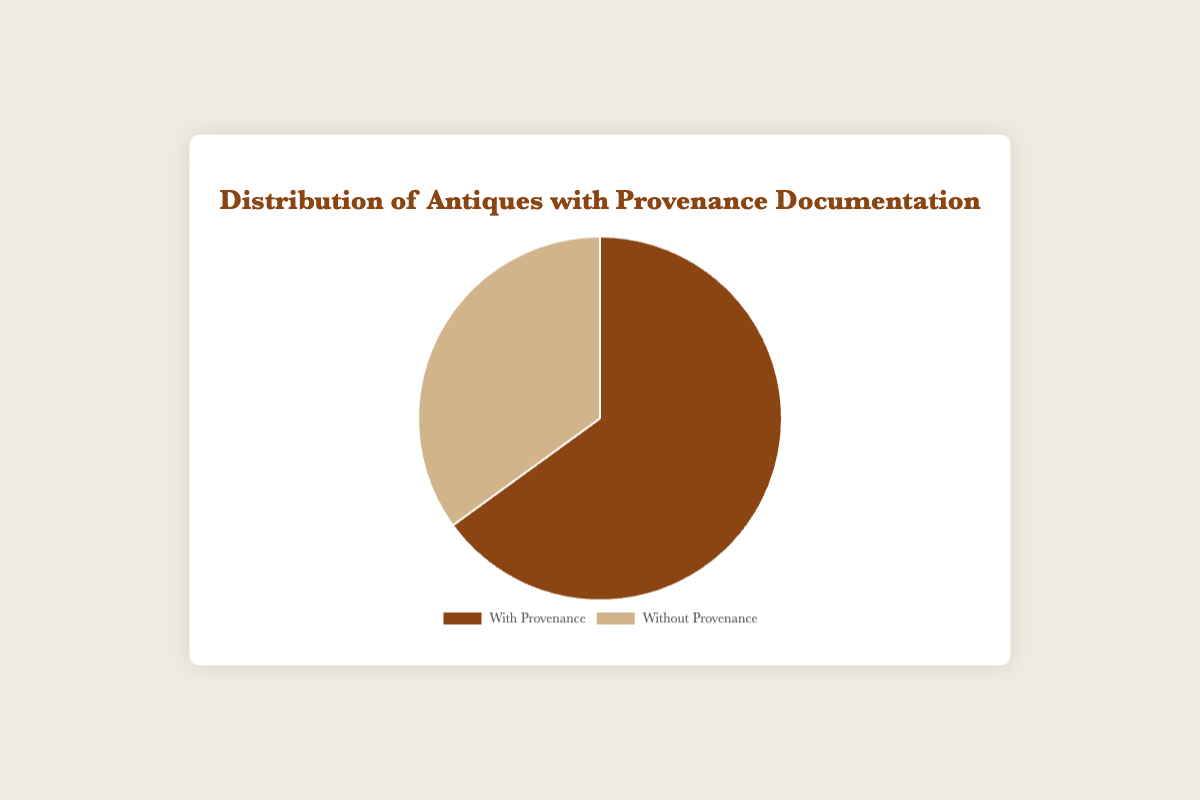What's the percentage of antiques with provenance documentation? The pie chart shows that there are two segments: one for antiques with provenance and one for those without. The segment for antiques with provenance constitutes 65% of the total.
Answer: 65% What's the percentage of antiques without provenance documentation? The pie chart indicates that 35% of the antiques do not have provenance documentation. This is derived from the segment labeled "Without Provenance."
Answer: 35% Are there more antiques with provenance documentation or without? By comparing the sizes of the segments in the pie chart, the segment for "With Provenance" is larger than that for "Without Provenance," indicating more antiques have provenance documentation.
Answer: With Provenance By how much is the proportion of antiques with provenance documentation greater than those without? The proportion of antiques with provenance documentation (65%) is greater than those without (35%) by comparing the segments. The difference is 65% - 35% = 30%.
Answer: 30% What is the total number of antiques with provenance documentation if there are 100 antiques in total? Given that 65% of the 100 antiques have provenance documentation, the number is calculated as (65% of 100) = 0.65 x 100 = 65.
Answer: 65 What is the total number of antiques without provenance documentation if there are 100 antiques in total? Based on the pie chart, 35% of the 100 antiques are without provenance documentation. Thus, the number is (35% of 100) = 0.35 x 100 = 35.
Answer: 35 What color indicates the portion with provenance documentation on the pie chart? The pie chart uses distinct colors for each segment, and the segment representing "With Provenance" is colored brown.
Answer: Brown How would you visually identify the segment representing antiques without provenance? The segment representing "Without Provenance" can be identified by its lighter tan color.
Answer: Tan 